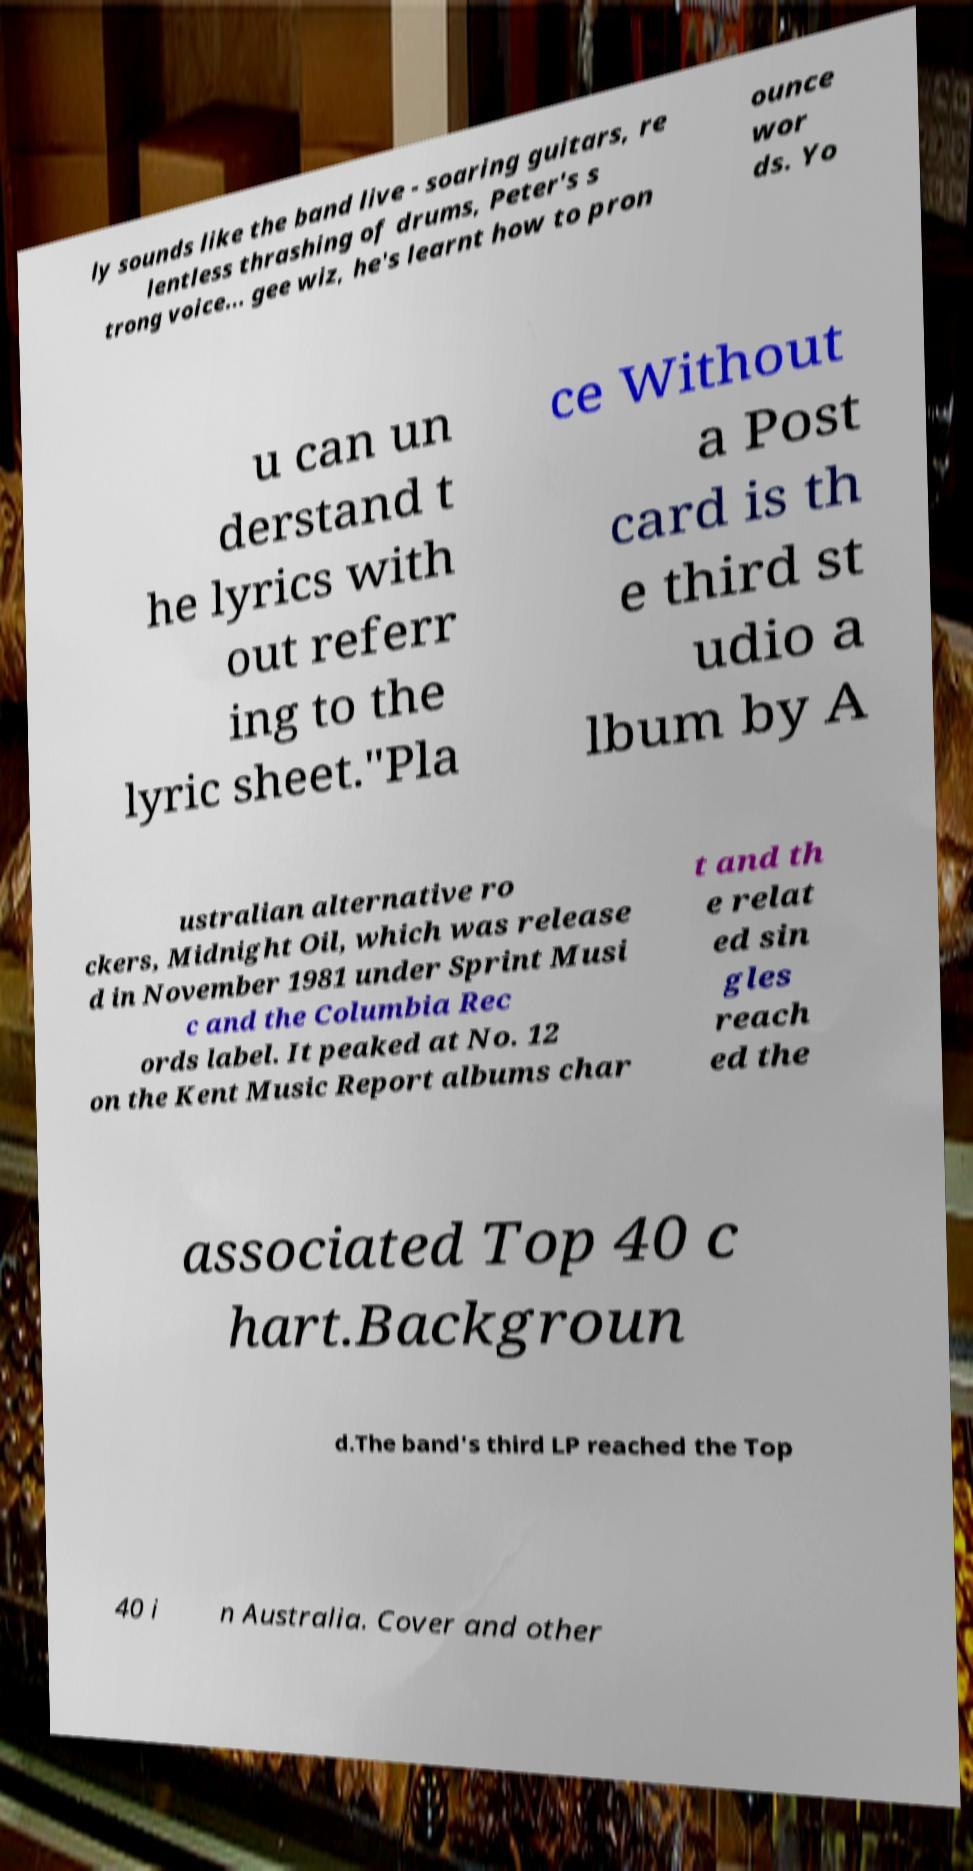Could you extract and type out the text from this image? ly sounds like the band live - soaring guitars, re lentless thrashing of drums, Peter's s trong voice... gee wiz, he's learnt how to pron ounce wor ds. Yo u can un derstand t he lyrics with out referr ing to the lyric sheet."Pla ce Without a Post card is th e third st udio a lbum by A ustralian alternative ro ckers, Midnight Oil, which was release d in November 1981 under Sprint Musi c and the Columbia Rec ords label. It peaked at No. 12 on the Kent Music Report albums char t and th e relat ed sin gles reach ed the associated Top 40 c hart.Backgroun d.The band's third LP reached the Top 40 i n Australia. Cover and other 